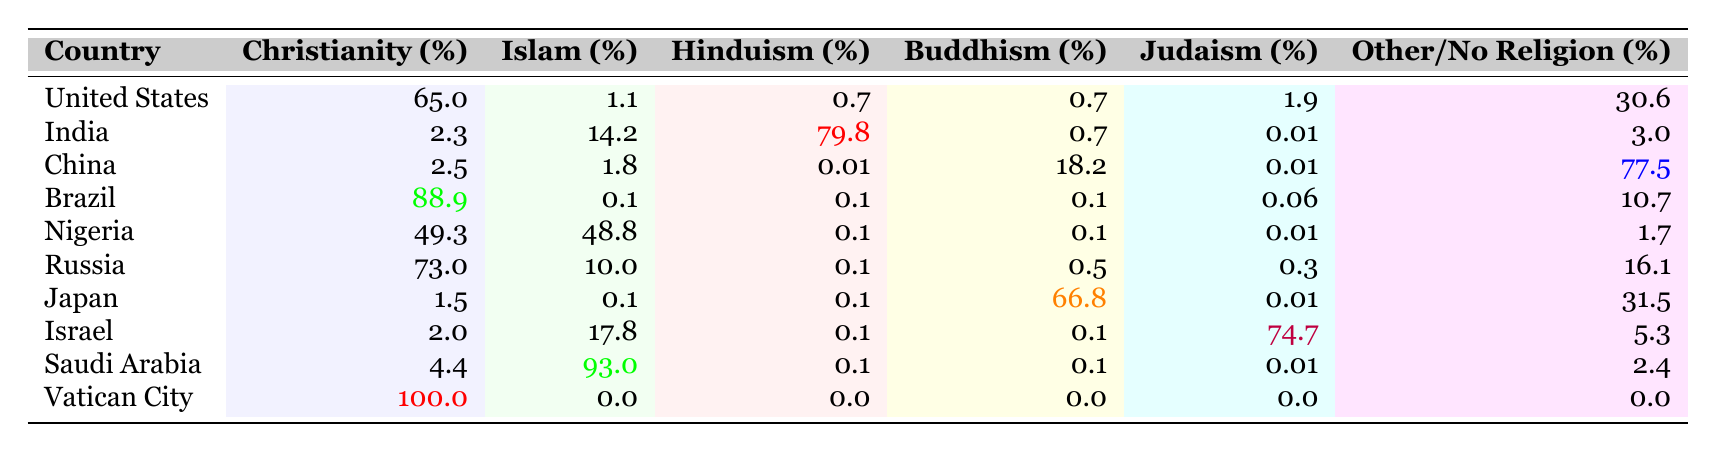What is the percentage of Christians in Nigeria? The table shows that Nigeria has a Christianity percentage of 49.3%.
Answer: 49.3% Which country has the highest percentage of Buddhism? Observing the table, Japan has the highest Buddhism percentage at 66.8%.
Answer: Japan Is the majority of the population in Saudi Arabia Muslim? The table indicates that 93% of the population in Saudi Arabia adheres to Islam, which constitutes the majority.
Answer: Yes What is the difference between the percentage of Christians in Brazil and Islam in the same country? The percentage of Christians in Brazil is 88.9%, and the percentage of Islam is 0.1%. The difference is 88.9% - 0.1% = 88.8%.
Answer: 88.8% What is the total percentage of non-religious individuals in China? The table indicates that 77.5% of the population in China adheres to "Other/No Religion." This is the total for non-religious individuals.
Answer: 77.5% Which country exhibits the lowest percentage of Hinduism? The table displays that both Russia and Brazil have the lowest recorded Hinduism percentages at 0.1%.
Answer: Russia and Brazil What is the average percentage of Islam among the given countries? The total percentage of Islam across the countries is (1.1 + 14.2 + 1.8 + 0.1 + 48.8 + 10 + 0.1 + 17.8 + 93 + 0) =  186.9%. There are 10 countries, so the average is 186.9% / 10 = 18.69%.
Answer: 18.69% How many countries have a Christianity percentage above 60%? By inspecting the table, United States (65%), Brazil (88.9%), and Russia (73%) have Christianity percentages above 60%. Thus, there are three such countries.
Answer: 3 Is there any country where Hinduism constitutes more than 75% of the population? The table shows that only India has a Hinduism percentage of 79.8%, which is more than 75%.
Answer: Yes What is the combined percentage of Christianity and Islam in Israel? The table shows Christianity at 2.0% and Islam at 17.8% in Israel. Adding these gives 2.0% + 17.8% = 19.8%.
Answer: 19.8% 